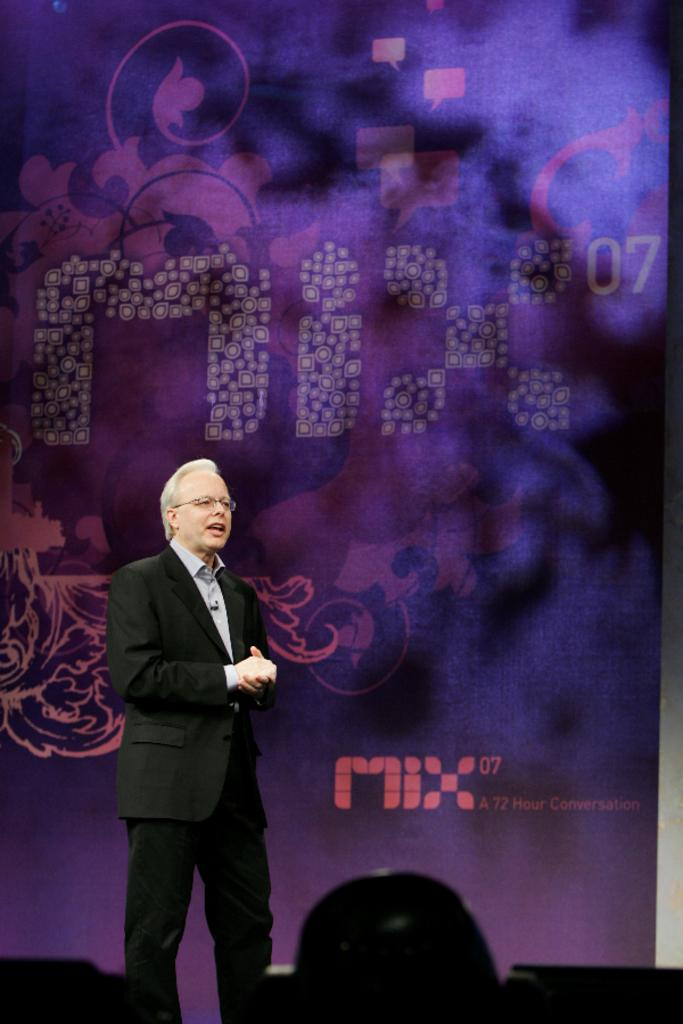Who is present in the image? There is a man in the image. What can be seen on the man's face? The man is wearing spectacles. What is visible in the background of the image? There is a screen in the background of the image. What can be found at the bottom of the image? There are objects at the bottom of the image. What caption is written below the man in the image? There is no caption written below the man in the image. How is the man affiliated with the organization in the image? There is no organization present in the image, and the man's affiliation cannot be determined. 